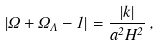<formula> <loc_0><loc_0><loc_500><loc_500>\left | \Omega + \Omega _ { \Lambda } - 1 \right | = \frac { | k | } { a ^ { 2 } H ^ { 2 } } \, ,</formula> 